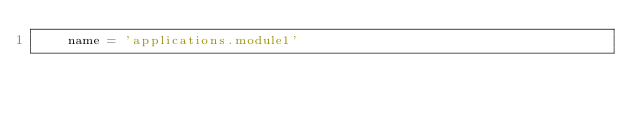Convert code to text. <code><loc_0><loc_0><loc_500><loc_500><_Python_>    name = 'applications.module1'
</code> 